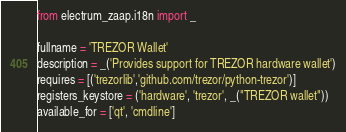Convert code to text. <code><loc_0><loc_0><loc_500><loc_500><_Python_>from electrum_zaap.i18n import _

fullname = 'TREZOR Wallet'
description = _('Provides support for TREZOR hardware wallet')
requires = [('trezorlib','github.com/trezor/python-trezor')]
registers_keystore = ('hardware', 'trezor', _("TREZOR wallet"))
available_for = ['qt', 'cmdline']

</code> 